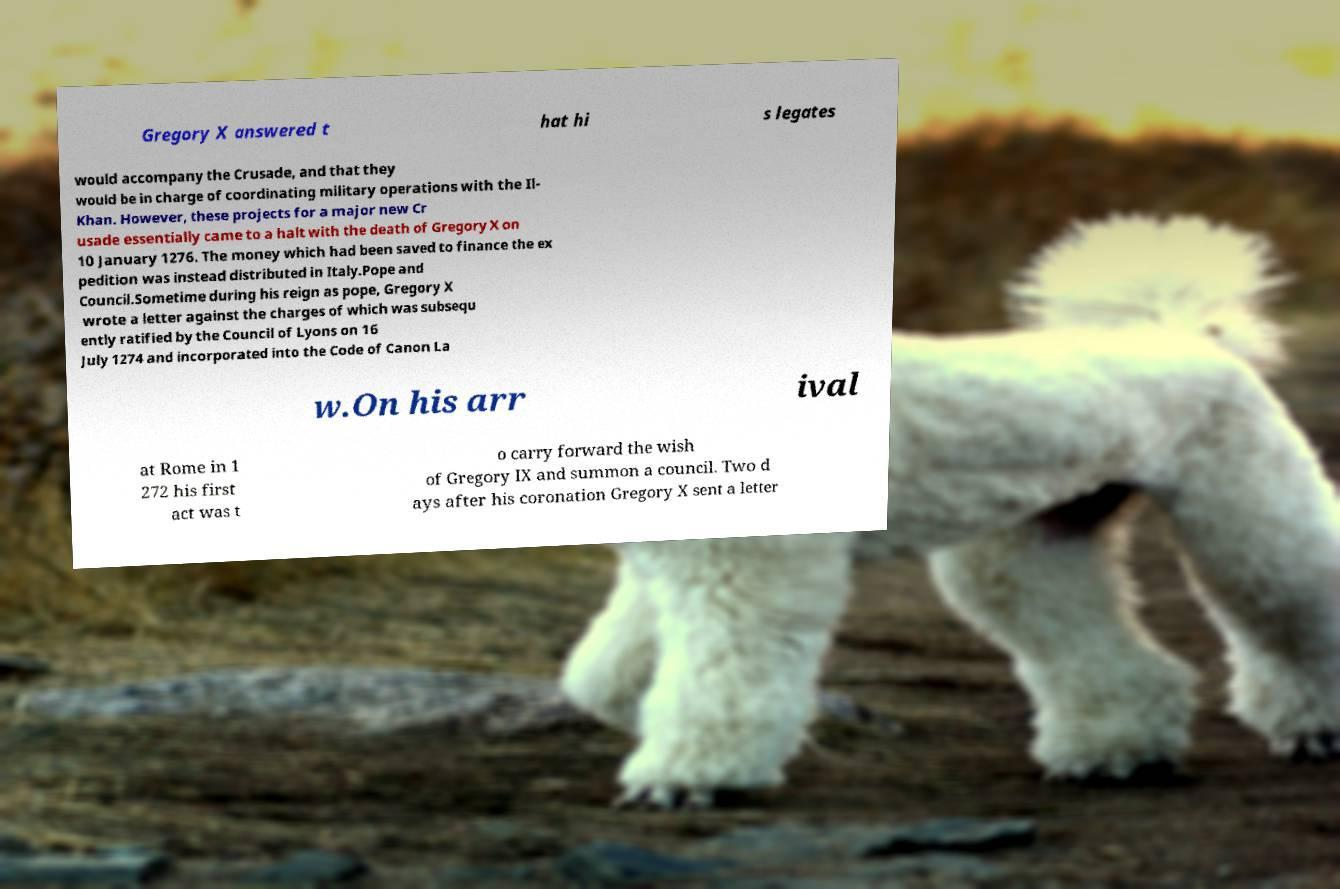Please read and relay the text visible in this image. What does it say? Gregory X answered t hat hi s legates would accompany the Crusade, and that they would be in charge of coordinating military operations with the Il- Khan. However, these projects for a major new Cr usade essentially came to a halt with the death of Gregory X on 10 January 1276. The money which had been saved to finance the ex pedition was instead distributed in Italy.Pope and Council.Sometime during his reign as pope, Gregory X wrote a letter against the charges of which was subsequ ently ratified by the Council of Lyons on 16 July 1274 and incorporated into the Code of Canon La w.On his arr ival at Rome in 1 272 his first act was t o carry forward the wish of Gregory IX and summon a council. Two d ays after his coronation Gregory X sent a letter 